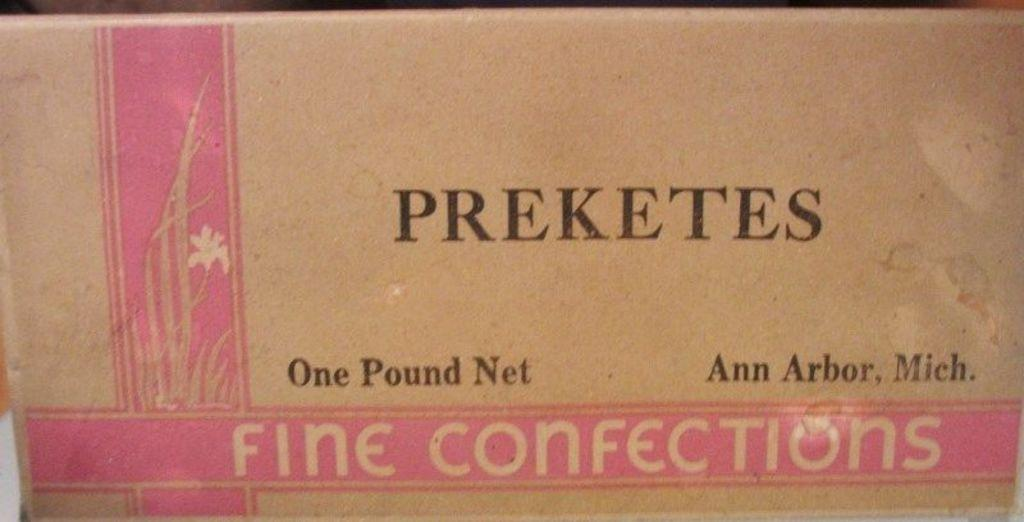<image>
Describe the image concisely. A one pound cardboard box of Preketes Fine confections. 